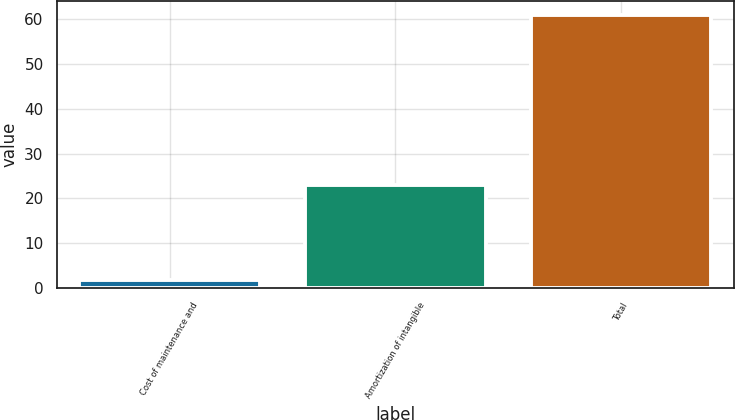Convert chart. <chart><loc_0><loc_0><loc_500><loc_500><bar_chart><fcel>Cost of maintenance and<fcel>Amortization of intangible<fcel>Total<nl><fcel>1.8<fcel>23<fcel>60.9<nl></chart> 